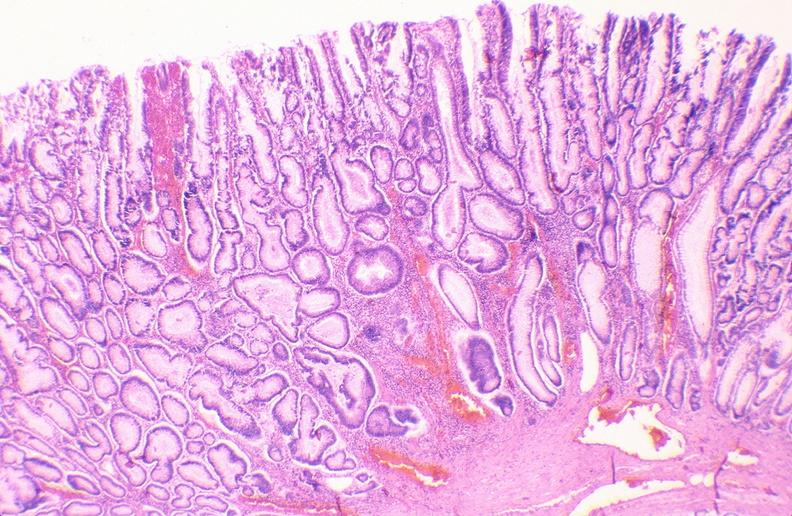s acid present?
Answer the question using a single word or phrase. No 